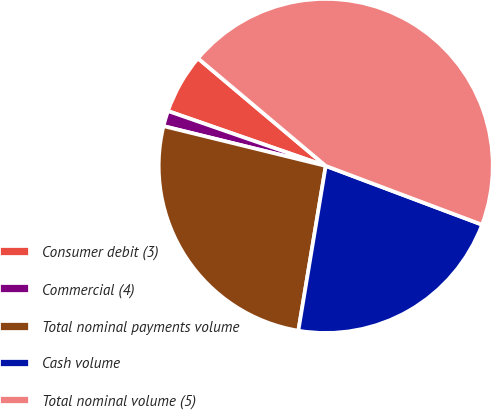Convert chart to OTSL. <chart><loc_0><loc_0><loc_500><loc_500><pie_chart><fcel>Consumer debit (3)<fcel>Commercial (4)<fcel>Total nominal payments volume<fcel>Cash volume<fcel>Total nominal volume (5)<nl><fcel>5.81%<fcel>1.5%<fcel>26.21%<fcel>21.9%<fcel>44.59%<nl></chart> 